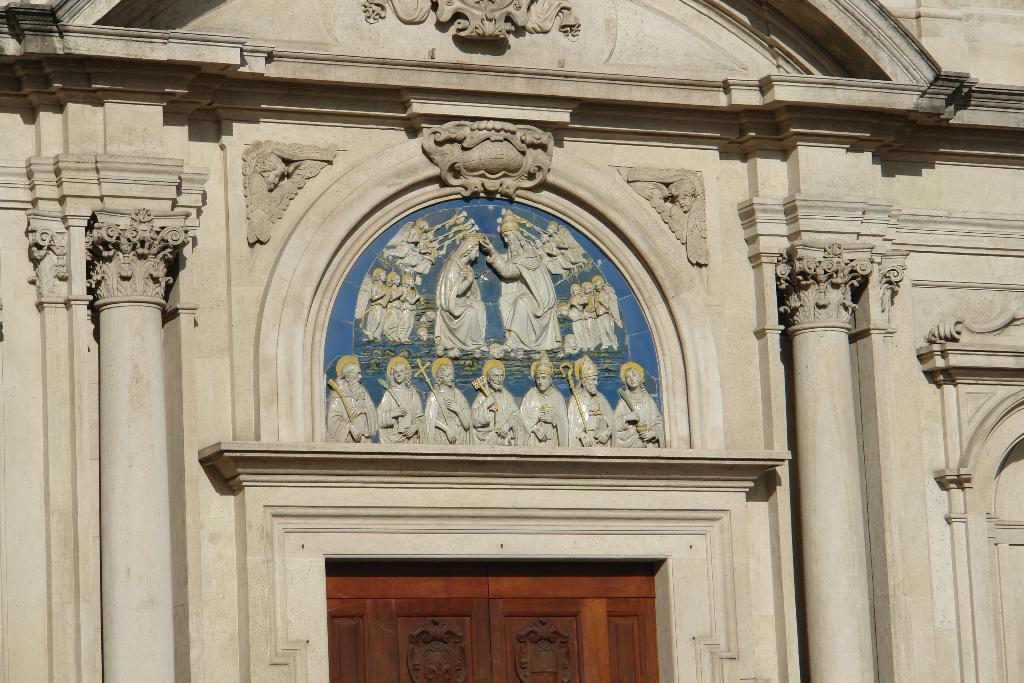What type of artwork can be seen in the image? There are carvings and sculptures in the image. What architectural elements are present in the image? There are pillars for a wall and a door in the image. Can you describe the arrangement of the sculptures in the image? The sculptures are located above the door in the image. How many chickens are present in the image? There are no chickens present in the image. What color is the balloon tied to the sculpture in the image? There is no balloon present in the image. 